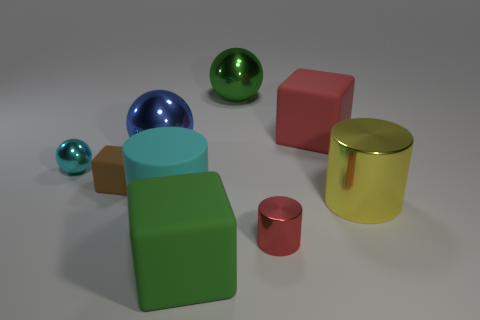Add 1 matte objects. How many objects exist? 10 Subtract all cubes. How many objects are left? 6 Add 1 yellow metallic cylinders. How many yellow metallic cylinders are left? 2 Add 2 metallic objects. How many metallic objects exist? 7 Subtract 1 cyan spheres. How many objects are left? 8 Subtract all red metal balls. Subtract all big metallic cylinders. How many objects are left? 8 